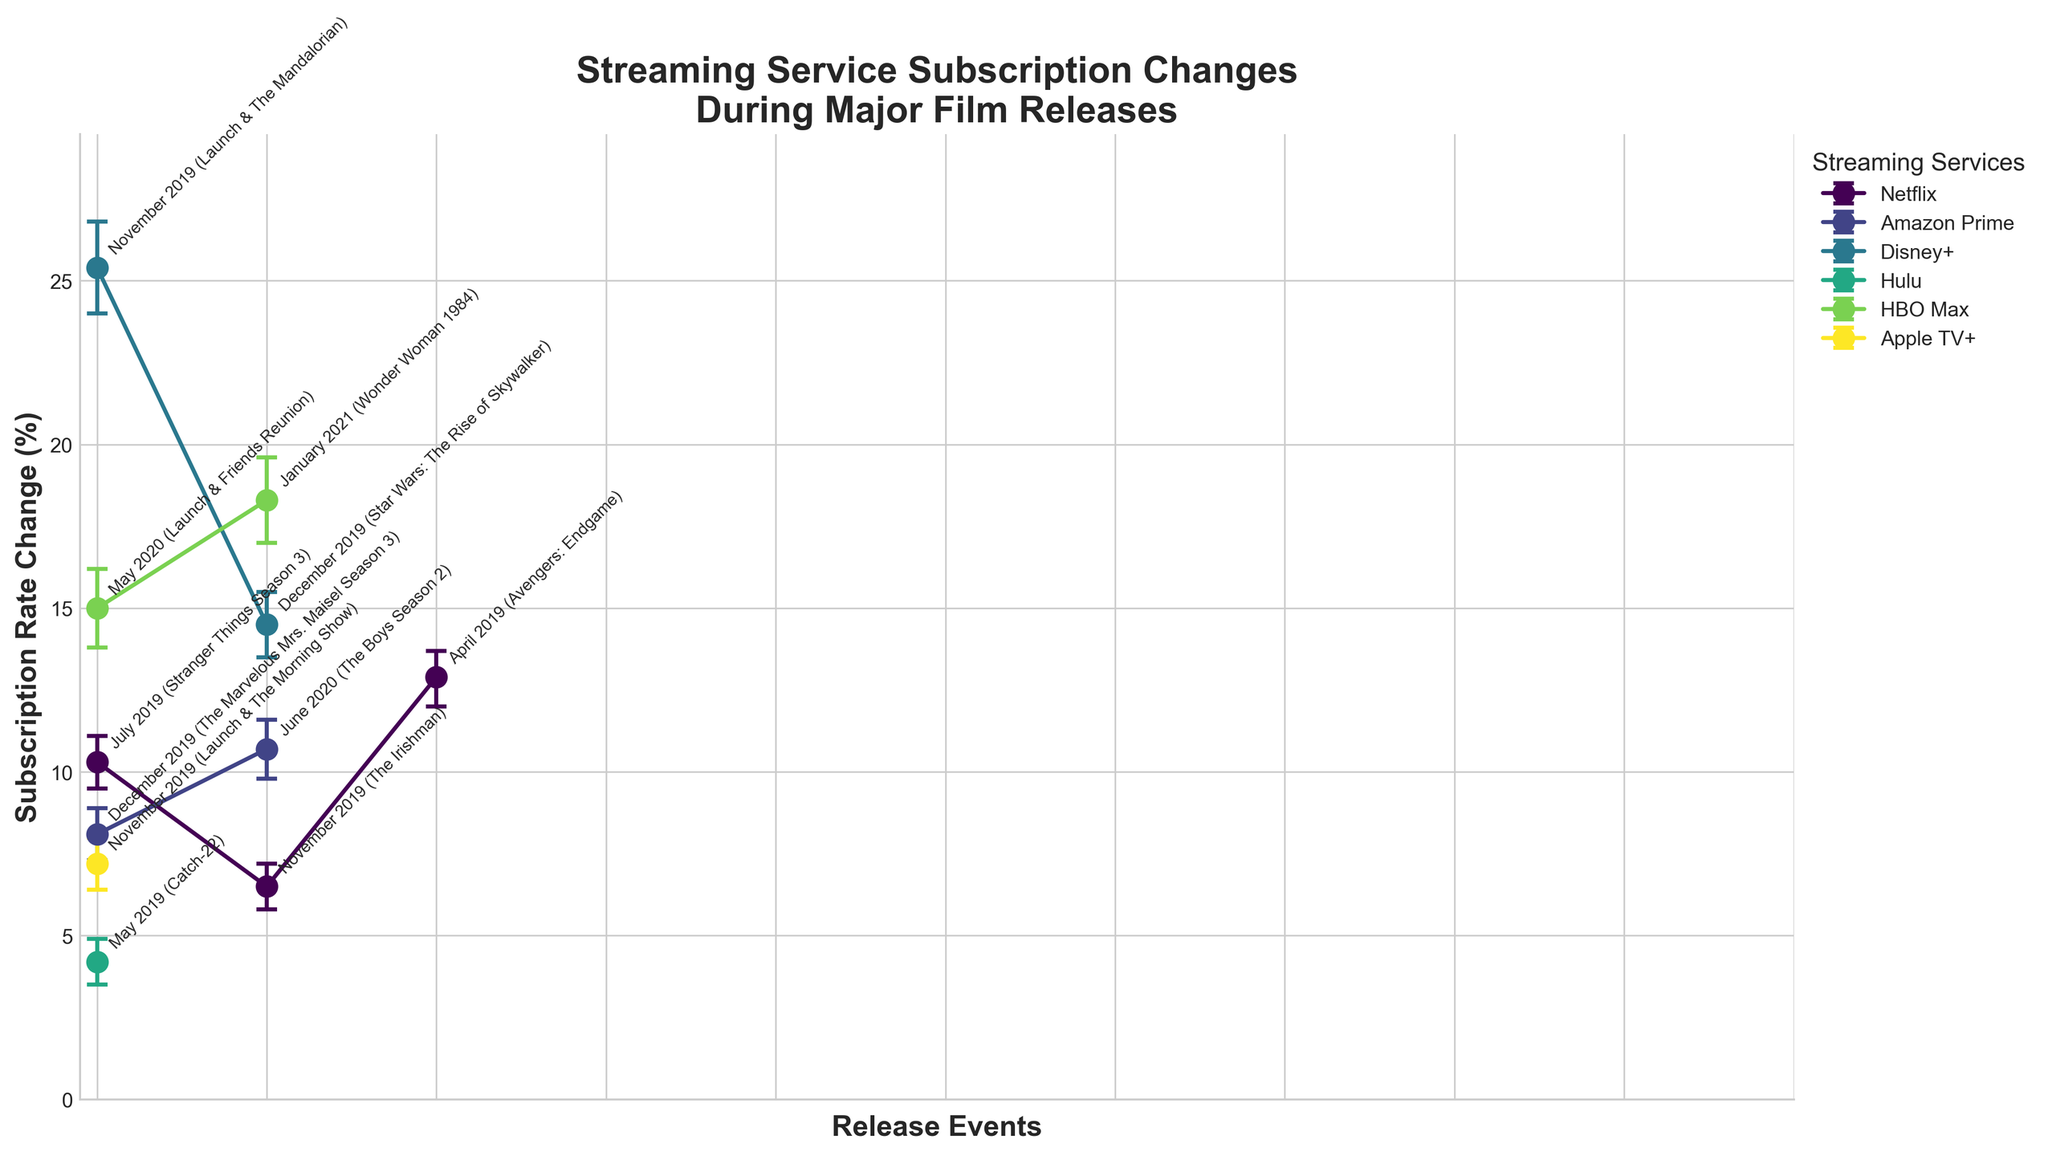What is the title of the plot? The title is displayed at the top of the plot in large, bold text. It provides a brief summary of the content of the plot.
Answer: Streaming Service Subscription Changes During Major Film Releases Which streaming service shows the highest subscription rate change? By looking at the y-axis (Subscription Rate Change) and identifying the highest point among all the lines, you can see that Disney+ has the highest subscription rate change.
Answer: Disney+ What is the subscription rate change for Netflix during the release of Stranger Things Season 3? Locate the data point for Netflix during July 2019, marked by the label "July 2019 (Stranger Things Season 3)." The corresponding y-value indicates the subscription rate change.
Answer: 10.3% Which film release month is associated with the smallest subscription rate change? Look for the data point closest to the bottom of the y-axis across all streaming services. Identify the label next to this data point.
Answer: May 2019 (Catch-22) on Hulu Which streaming service had the largest confidence interval during the release of Wonder Woman 1984? Compare the error bars surrounding each data point. The length of the error bars indicates the size of the confidence interval. HBO Max in January 2021 shows the largest error bars.
Answer: HBO Max What is the difference in subscription rate change between Netflix in April 2019 (Avengers: Endgame) and November 2019 (The Irishman)? Subtract the subscription rate change for November 2019 from that of April 2019 for Netflix. April: 12.9%, November: 6.5%, Difference: 12.9% - 6.5% = 6.4%.
Answer: 6.4% Which film release caused the highest subscription rate change for Disney+? Identify the points related to Disney+ and compare their y-values. The highest point corresponds to November 2019 (Launch & The Mandalorian).
Answer: November 2019 (Launch & The Mandalorian) What is the average subscription rate change for Amazon Prime? Sum the subscription rate changes for Amazon Prime and divide by the number of data points. (8.1% + 10.7%) / 2 = 9.4%.
Answer: 9.4% How do the confidence intervals for Netflix during the release of Stranger Things Season 3 and Avengers: Endgame compare? Compare the length of the error bars for the two data points for Netflix. Stranger Things Season 3: 9.5% to 11.1%, Avengers: Endgame: 12.0% to 13.7%, Both intervals overlap but Endgame has a higher range.
Answer: Endgame's range is higher but both have overlapping intervals 